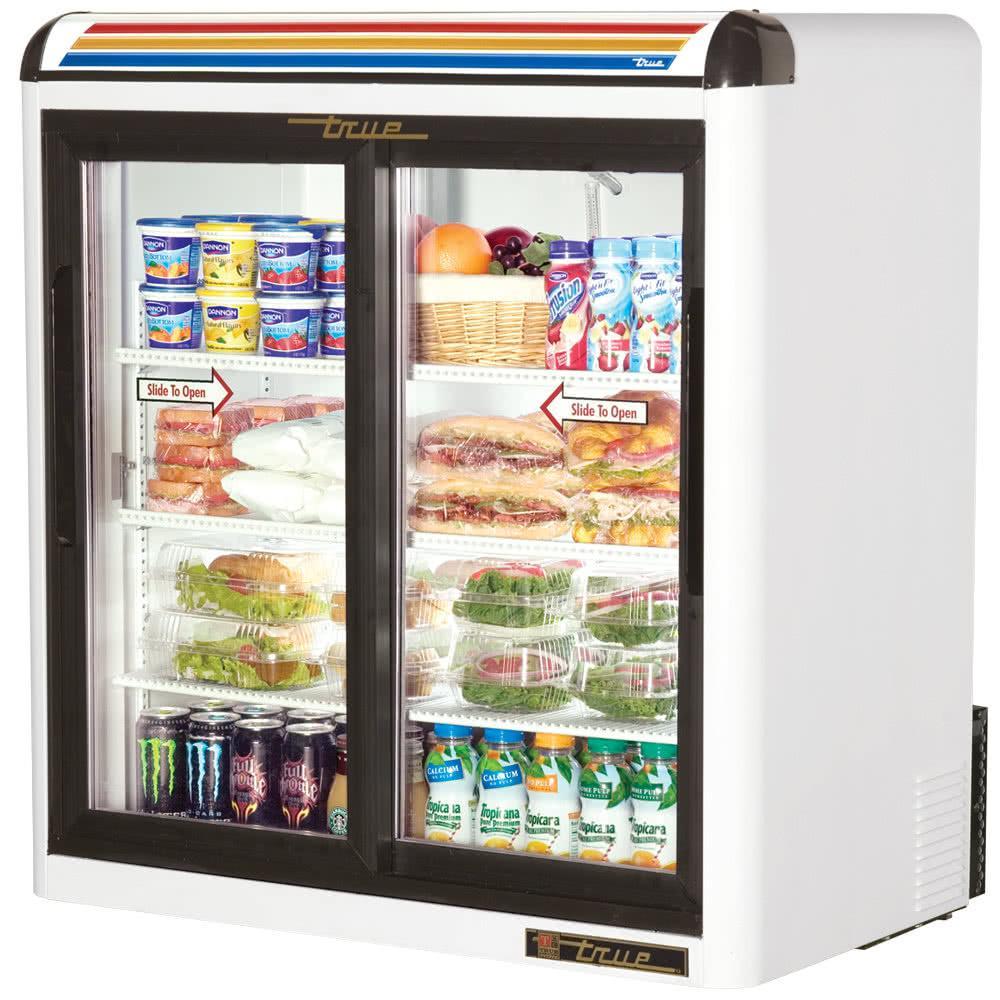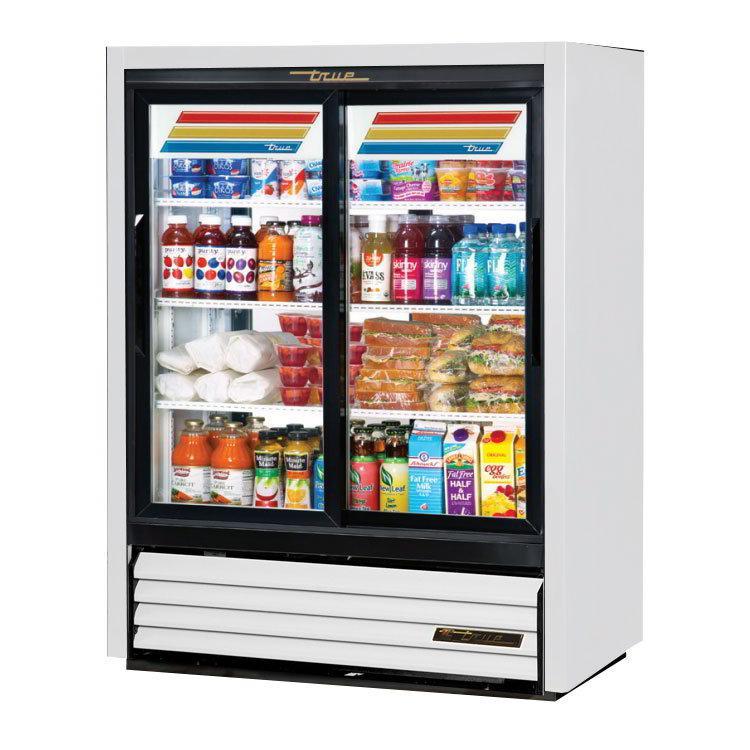The first image is the image on the left, the second image is the image on the right. Considering the images on both sides, is "At least two gallons of milk are on the bottom shelf." valid? Answer yes or no. No. The first image is the image on the left, the second image is the image on the right. Assess this claim about the two images: "The cooler display in the right image has three colored lines across the top that run nearly the width of the machine.". Correct or not? Answer yes or no. No. 